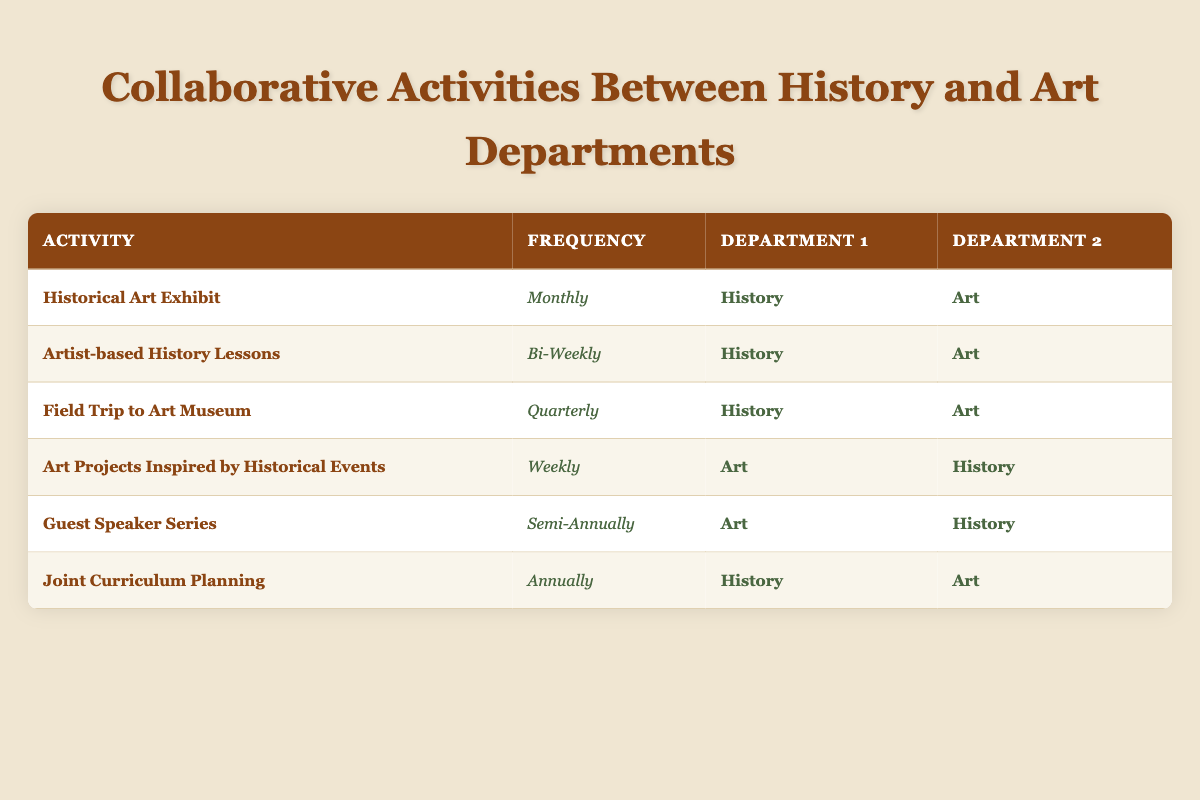What is the frequency of the Historical Art Exhibit activity? The table clearly lists the Historical Art Exhibit as being held monthly, as it appears in the 'Frequency' column next to the activity name.
Answer: Monthly How many activities are held weekly? From the table, we can identify that only one activity—Art Projects Inspired by Historical Events—is held weekly, as indicated in the 'Frequency' column.
Answer: 1 Is there a collaborative activity that occurs annually? The table includes the Joint Curriculum Planning activity which has an annual frequency, confirming that such an activity exists.
Answer: Yes Which department is involved most frequently based on the data? By examining the frequency of activities involving both departments, History is involved in 4 activities (Historical Art Exhibit, Artist-based History Lessons, Field Trip to Art Museum, and Joint Curriculum Planning) while Art is involved in 3 (Art Projects Inspired by Historical Events and Guest Speaker Series). Thus, History is more frequently involved.
Answer: History What is the average frequency of activities combined? To find the average frequency, we can convert the frequencies into a numerical format. There are 6 activities with respective frequencies of 1 (monthly), 2 (bi-weekly), 4 (quarterly), 3 (weekly), 6 (semi-annually), and 12 (annually). The total is 28 and dividing by the number of activities (6) gives us an average of approximately 4.67, meaning the average frequency is between quarterly and semi-annually.
Answer: 4.67 